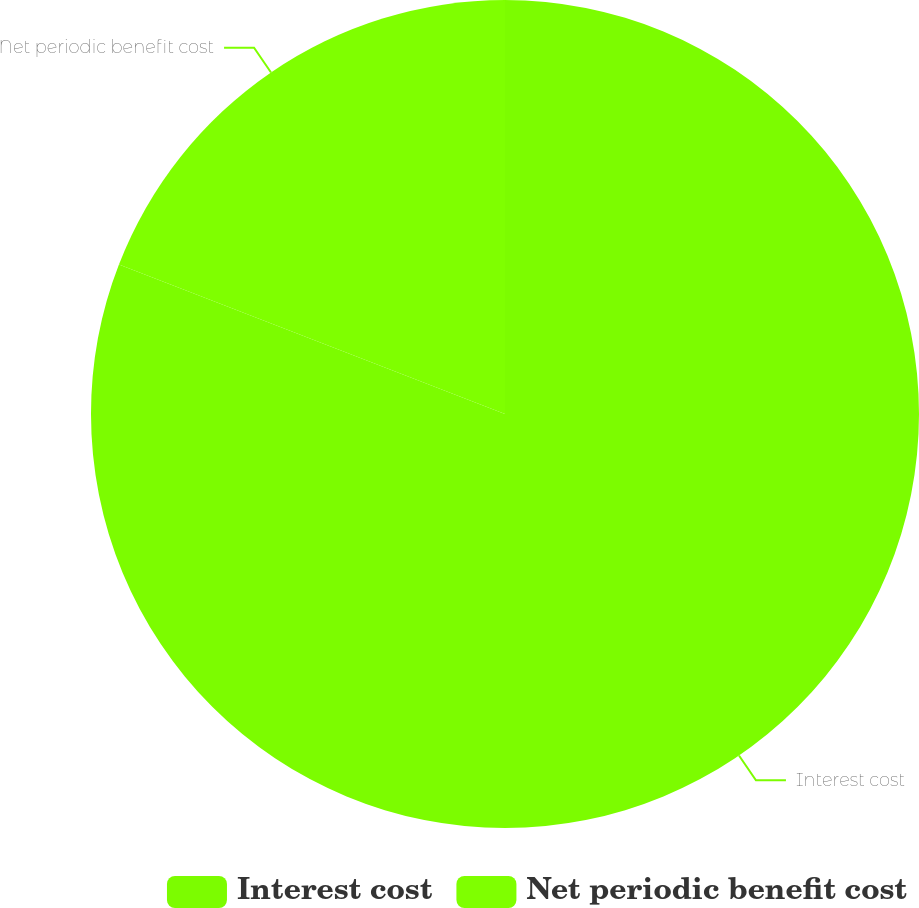Convert chart to OTSL. <chart><loc_0><loc_0><loc_500><loc_500><pie_chart><fcel>Interest cost<fcel>Net periodic benefit cost<nl><fcel>80.88%<fcel>19.12%<nl></chart> 